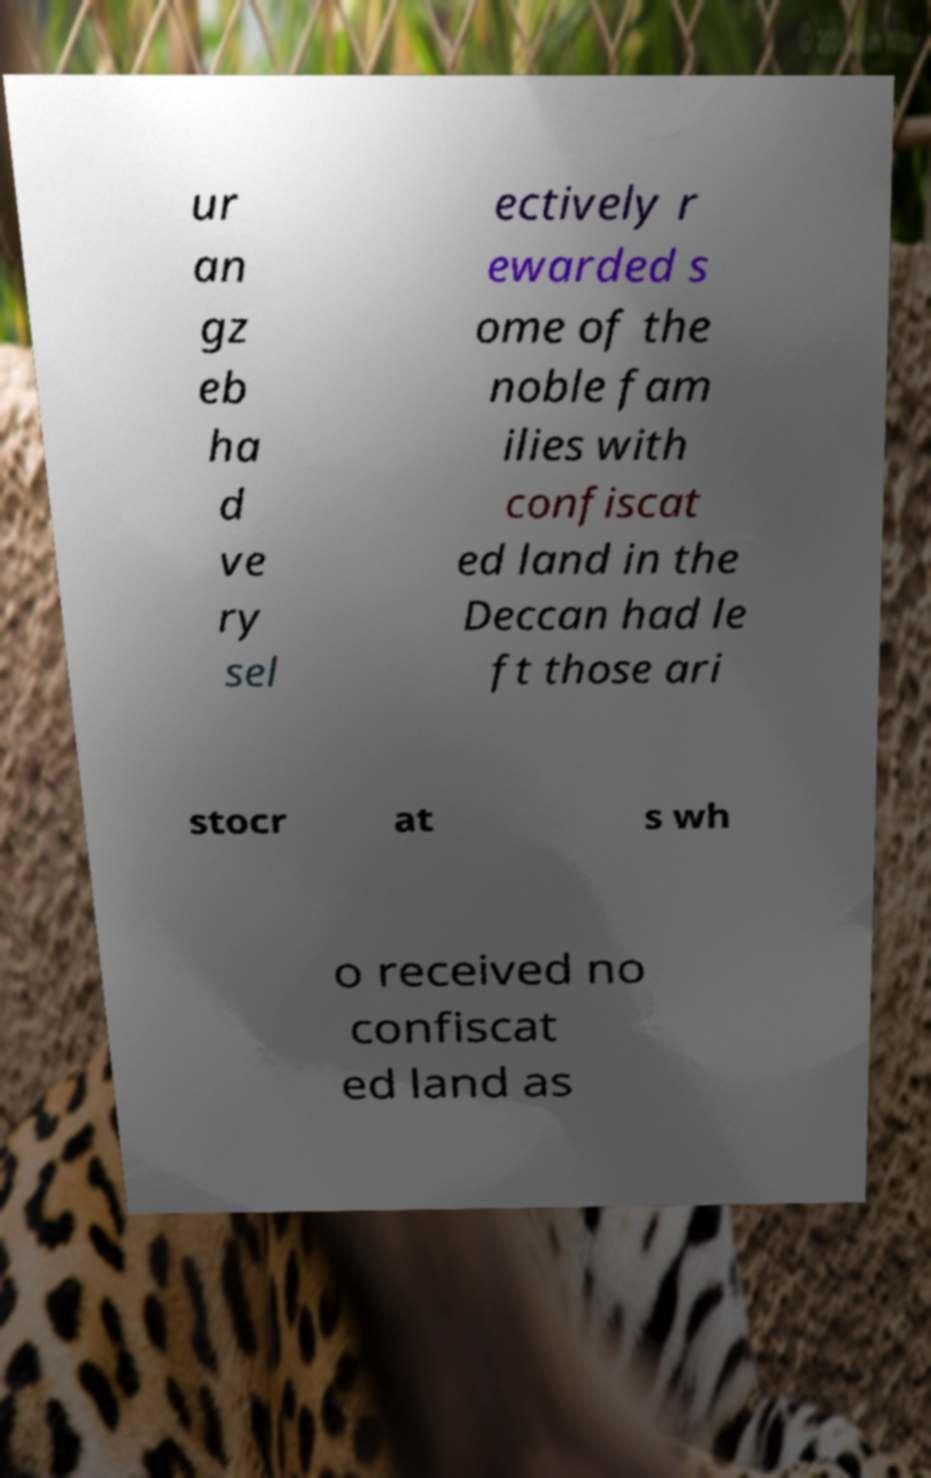Can you accurately transcribe the text from the provided image for me? ur an gz eb ha d ve ry sel ectively r ewarded s ome of the noble fam ilies with confiscat ed land in the Deccan had le ft those ari stocr at s wh o received no confiscat ed land as 